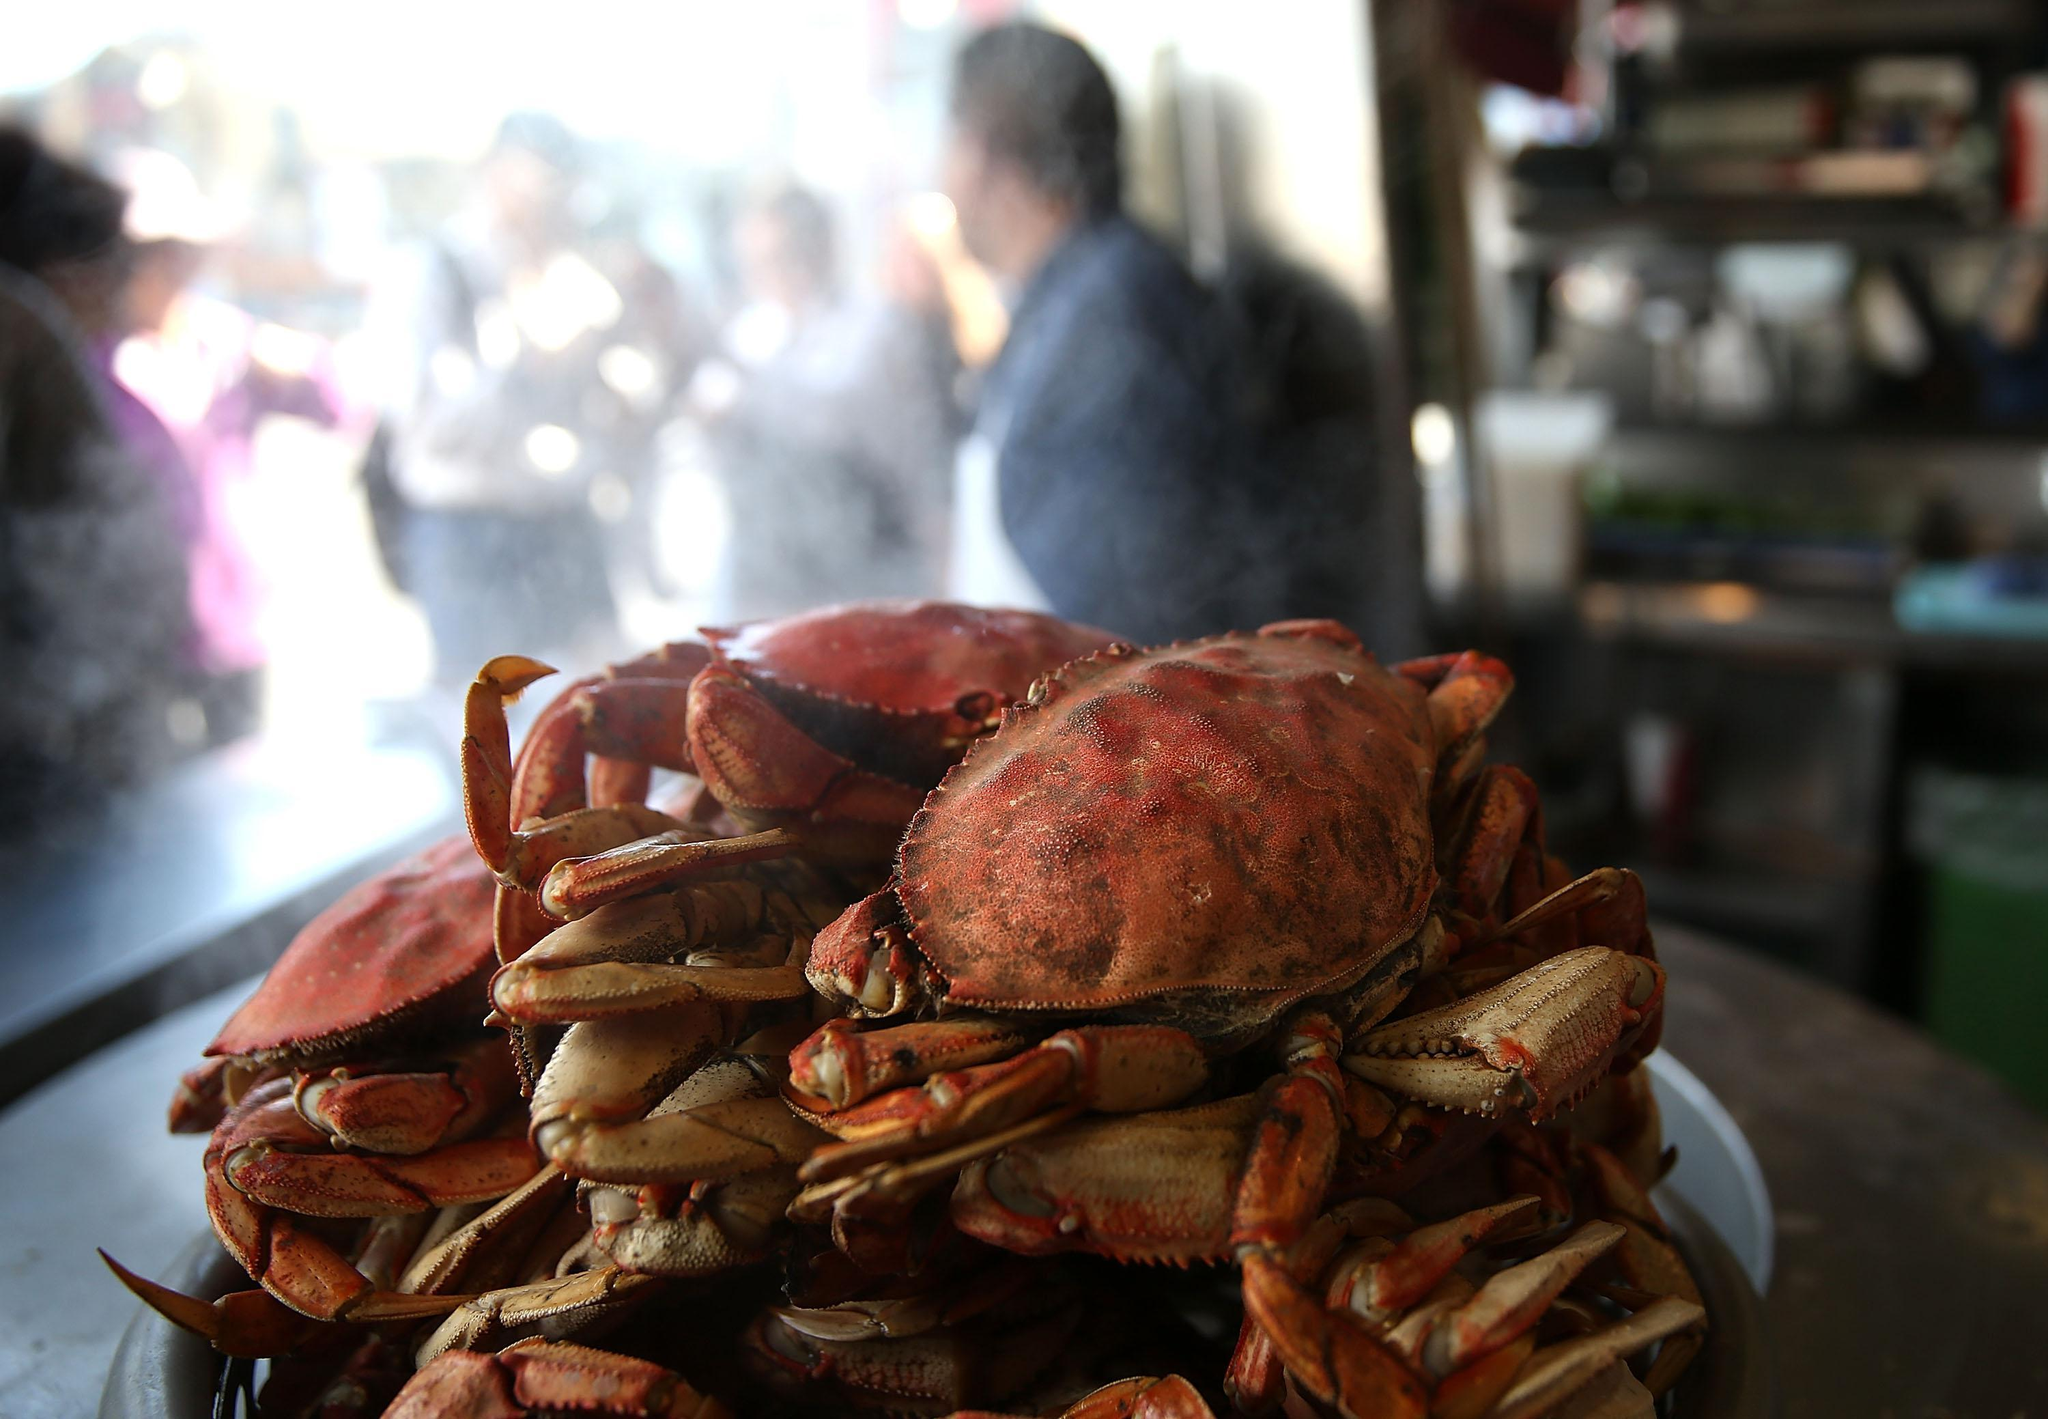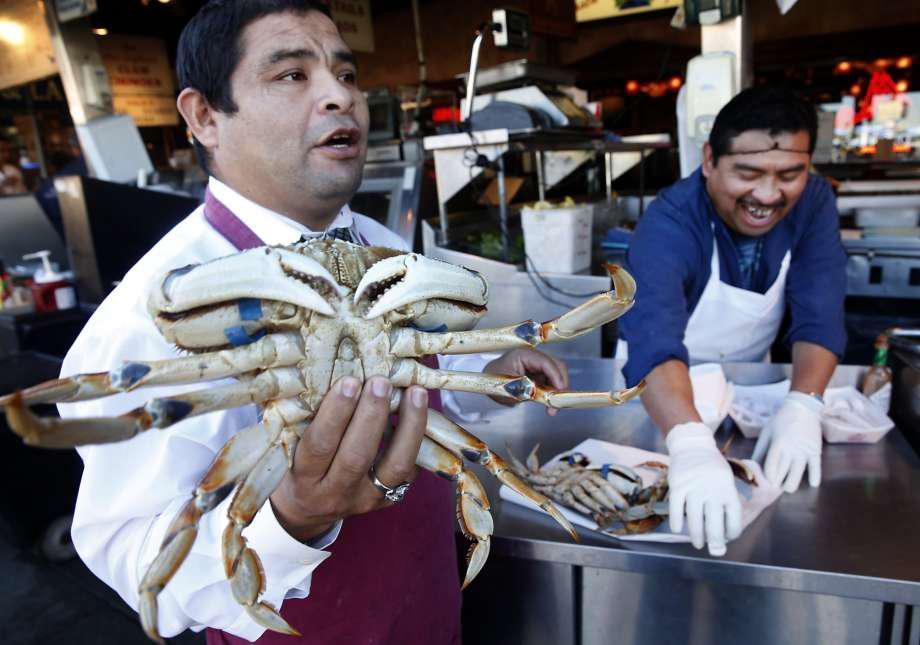The first image is the image on the left, the second image is the image on the right. For the images displayed, is the sentence "A man is holding one of the crabs at chest height in one of the images." factually correct? Answer yes or no. Yes. The first image is the image on the left, the second image is the image on the right. Evaluate the accuracy of this statement regarding the images: "In the right image, a man is holding a crab up belly-side forward in one bare hand.". Is it true? Answer yes or no. Yes. 